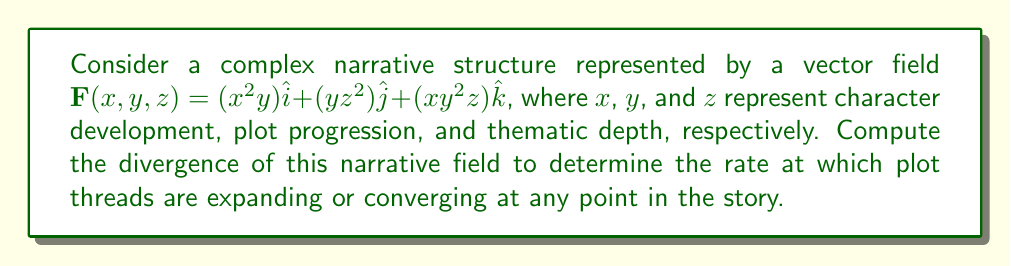Solve this math problem. To compute the divergence of the narrative field, we need to calculate the sum of the partial derivatives of each component with respect to its corresponding variable. The divergence is given by:

$$\nabla \cdot \mathbf{F} = \frac{\partial F_x}{\partial x} + \frac{\partial F_y}{\partial y} + \frac{\partial F_z}{\partial z}$$

Let's calculate each partial derivative:

1. $\frac{\partial F_x}{\partial x} = \frac{\partial}{\partial x}(x^2y) = 2xy$

2. $\frac{\partial F_y}{\partial y} = \frac{\partial}{\partial y}(yz^2) = z^2$

3. $\frac{\partial F_z}{\partial z} = \frac{\partial}{\partial z}(xy^2z) = xy^2$

Now, we sum these partial derivatives:

$$\nabla \cdot \mathbf{F} = 2xy + z^2 + xy^2$$

This expression represents the divergence of the narrative field at any point $(x,y,z)$ in the story structure.
Answer: $2xy + z^2 + xy^2$ 